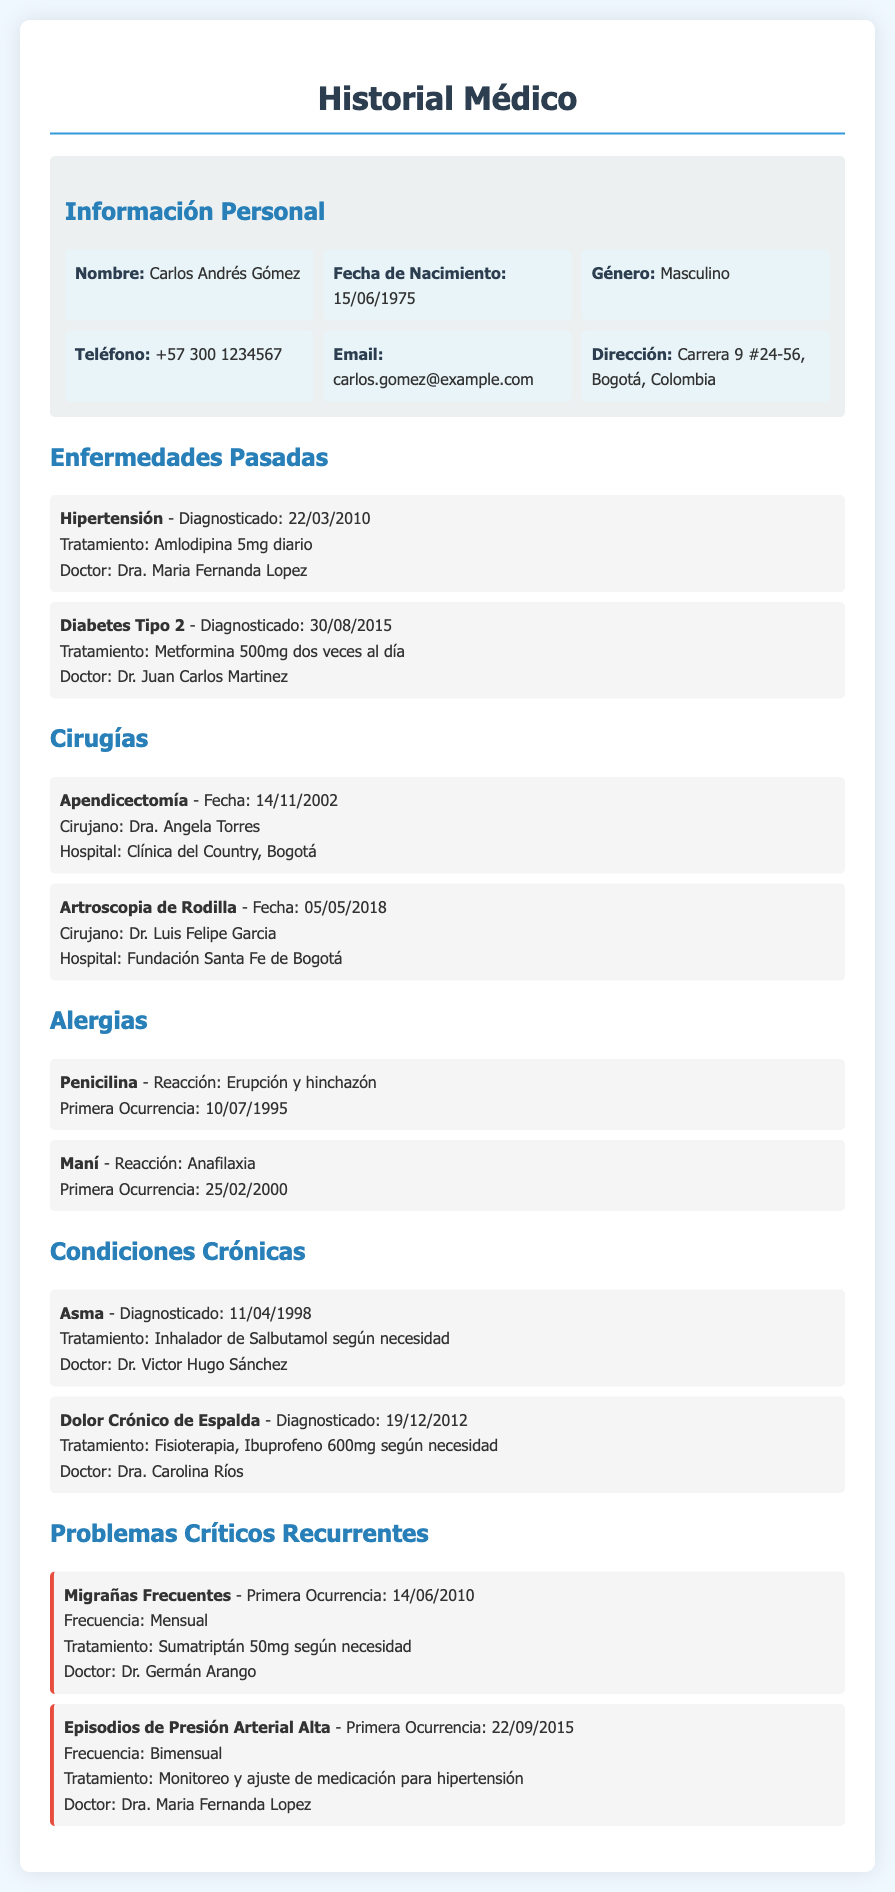¿Qué es la enfermedad diagnosticada el 22 de marzo de 2010? La enfermedad diagnosticada en esa fecha es Hipertensión, según la sección de Enfermedades Pasadas del historial médico.
Answer: Hipertensión ¿Cuál es el tratamiento para la Diabetes Tipo 2? El tratamiento para la Diabetes Tipo 2, como se indica en el documento, es Metformina 500mg dos veces al día.
Answer: Metformina 500mg dos veces al día ¿Cuándo fue realizada la apendicectomía? La apendicectomía fue realizada el 14 de noviembre de 2002, según la lista de cirugías en el documento.
Answer: 14/11/2002 ¿Cuál es la reacción a la Penicilina? La reacción a la Penicilina, como se menciona en la sección de Alergias, es Erupción y hinchazón.
Answer: Erupción y hinchazón ¿Cuál es el tratamiento para las migrañas frecuentes? El tratamiento para las migrañas frecuentes es Sumatriptán 50mg según necesidad, según la sección de Problemas Críticos Recurrentes.
Answer: Sumatriptán 50mg según necesidad ¿Cuál es la frecuencia de los episodios de presión arterial alta? La frecuencia de los episodios de presión arterial alta es Bimensual, tal como se indica en el historial médico.
Answer: Bimensual ¿Qué doctor atiende la condición de Asma? El doctor que atiende la condición de Asma es el Dr. Victor Hugo Sánchez, según la sección de Condiciones Crónicas.
Answer: Dr. Victor Hugo Sánchez ¿Cuál es la primera ocurrencia de la alergia al maní? La primera ocurrencia de la alergia al maní fue el 25 de febrero de 2000, como se señala en la sección de Alergias.
Answer: 25/02/2000 ¿En qué hospital se realizó la artroscopia de rodilla? La artroscopia de rodilla se realizó en la Fundación Santa Fe de Bogotá, según la lista de cirugías.
Answer: Fundación Santa Fe de Bogotá 